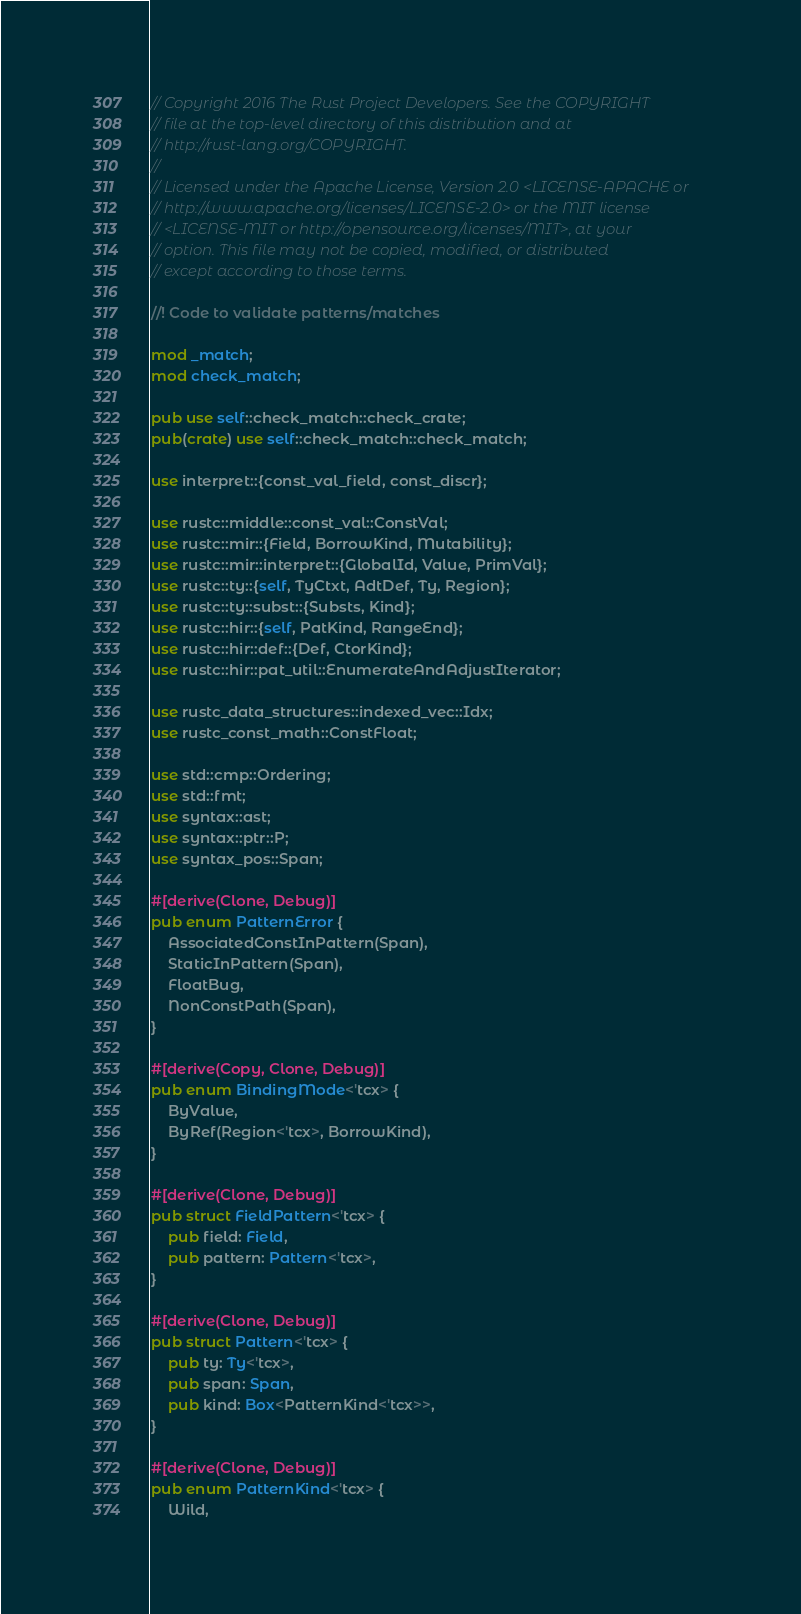<code> <loc_0><loc_0><loc_500><loc_500><_Rust_>// Copyright 2016 The Rust Project Developers. See the COPYRIGHT
// file at the top-level directory of this distribution and at
// http://rust-lang.org/COPYRIGHT.
//
// Licensed under the Apache License, Version 2.0 <LICENSE-APACHE or
// http://www.apache.org/licenses/LICENSE-2.0> or the MIT license
// <LICENSE-MIT or http://opensource.org/licenses/MIT>, at your
// option. This file may not be copied, modified, or distributed
// except according to those terms.

//! Code to validate patterns/matches

mod _match;
mod check_match;

pub use self::check_match::check_crate;
pub(crate) use self::check_match::check_match;

use interpret::{const_val_field, const_discr};

use rustc::middle::const_val::ConstVal;
use rustc::mir::{Field, BorrowKind, Mutability};
use rustc::mir::interpret::{GlobalId, Value, PrimVal};
use rustc::ty::{self, TyCtxt, AdtDef, Ty, Region};
use rustc::ty::subst::{Substs, Kind};
use rustc::hir::{self, PatKind, RangeEnd};
use rustc::hir::def::{Def, CtorKind};
use rustc::hir::pat_util::EnumerateAndAdjustIterator;

use rustc_data_structures::indexed_vec::Idx;
use rustc_const_math::ConstFloat;

use std::cmp::Ordering;
use std::fmt;
use syntax::ast;
use syntax::ptr::P;
use syntax_pos::Span;

#[derive(Clone, Debug)]
pub enum PatternError {
    AssociatedConstInPattern(Span),
    StaticInPattern(Span),
    FloatBug,
    NonConstPath(Span),
}

#[derive(Copy, Clone, Debug)]
pub enum BindingMode<'tcx> {
    ByValue,
    ByRef(Region<'tcx>, BorrowKind),
}

#[derive(Clone, Debug)]
pub struct FieldPattern<'tcx> {
    pub field: Field,
    pub pattern: Pattern<'tcx>,
}

#[derive(Clone, Debug)]
pub struct Pattern<'tcx> {
    pub ty: Ty<'tcx>,
    pub span: Span,
    pub kind: Box<PatternKind<'tcx>>,
}

#[derive(Clone, Debug)]
pub enum PatternKind<'tcx> {
    Wild,
</code> 